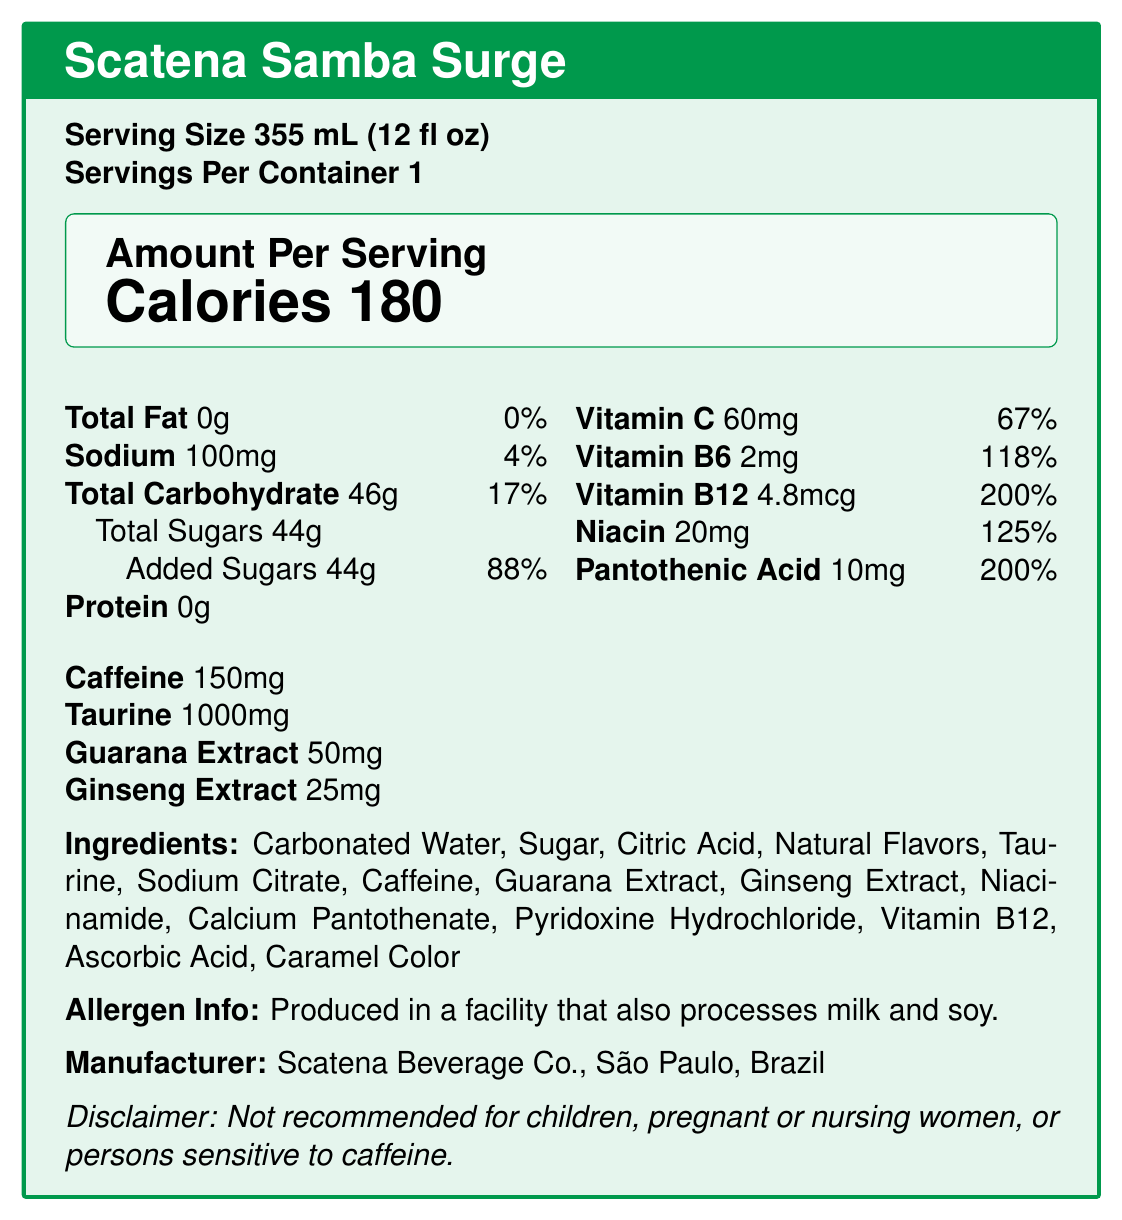what is the serving size of "Scatena Samba Surge"? The serving size is explicitly mentioned at the beginning of the Nutrition Facts box.
Answer: 355 mL (12 fl oz) how many calories are in one serving of this energy drink? The number of calories is located in the first bold box labeled "Amount Per Serving".
Answer: 180 what is the total carbohydrate content per serving? The total carbohydrate content per serving is listed under nutrients value as 46g.
Answer: 46g how much caffeine does one serving contain? The caffeine content per serving is clearly listed as 150mg.
Answer: 150mg what vitamins are included in "Scatena Samba Surge"? The vitamins included are listed along with their amounts and daily values under the nutrients section.
Answer: Vitamin C, Vitamin B6, Vitamin B12, Niacin, Pantothenic Acid what is the daily value percentage of Vitamin C per serving? The daily value percentage of Vitamin C is mentioned as 67% in the document.
Answer: 67% how much pantothenic acid does "Scatena Samba Surge" provide per serving? The document lists pantothenic acid content per serving as 10mg.
Answer: 10mg which ingredient is present in the highest amount in the drink? A. Sugar B. Citric Acid C. Carbonated Water D. Caffeine The ingredients are listed in descending order by weight, with "Carbonated Water" being the first ingredient.
Answer: C. Carbonated Water what is the primary sweetening agent in "Scatena Samba Surge"? A. Guarana Extract B. Ginseng Extract C. Sugar D. Caffeine Sugar is the second ingredient listed, indicating it is the primary sweetening agent.
Answer: C. Sugar by what percentage does the added sugar content of this drink contribute to the daily recommended value? A. 17% B. 67% C. 88% D. 125% The added sugars contribute 88% to the daily recommended value.
Answer: C. 88% is this energy drink recommended for children? The disclaimer states that it is not recommended for children.
Answer: No does "Scatena Samba Surge" contain any protein? The protein content is listed as 0g in the nutrition facts.
Answer: No identify two additional functional ingredients besides caffeine. These functional ingredients are explicitly listed in the document.
Answer: Taurine, Guarana Extract, Ginseng Extract describe the overall nutritional profile of "Scatena Samba Surge". This summary covers the key nutritional aspects presented in the document.
Answer: "Scatena Samba Surge" is an energy drink providing 180 calories per serving with no fat, protein, or fiber. It contains high levels of sugars (44g), a significant amount of caffeine (150mg), and notable quantities of vitamins C, B6, B12, Niacin, and Pantothenic Acid. Functional ingredients include Taurine, Guarana extract, and Ginseng extract, but it's not recommended for children or pregnant women. what exact percentage of the suggested daily value of Vitamin B12 does the drink provide? The document specifies that the drink provides 200% of the daily value for Vitamin B12.
Answer: 200% what is the country of origin of "Scatena Samba Surge"? The manufacturer is Scatena Beverage Co., São Paulo, Brazil.
Answer: Brazil is the product calorie content high, moderate, or low? A serving contains 180 calories, which is moderate for a single beverage serving.
Answer: Moderate can the energy drink's allergen information determine if it is safe for someone with a severe nut allergy to consume? The allergen info only states that it is produced in a facility that processes milk and soy, but nothing is mentioned about nuts.
Answer: Cannot be determined 